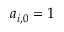Convert formula to latex. <formula><loc_0><loc_0><loc_500><loc_500>a _ { i , 0 } = 1</formula> 